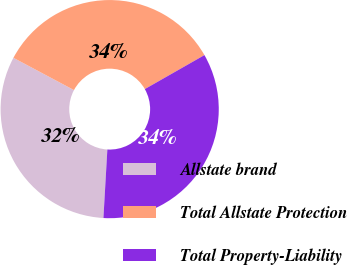<chart> <loc_0><loc_0><loc_500><loc_500><pie_chart><fcel>Allstate brand<fcel>Total Allstate Protection<fcel>Total Property-Liability<nl><fcel>31.88%<fcel>33.96%<fcel>34.16%<nl></chart> 